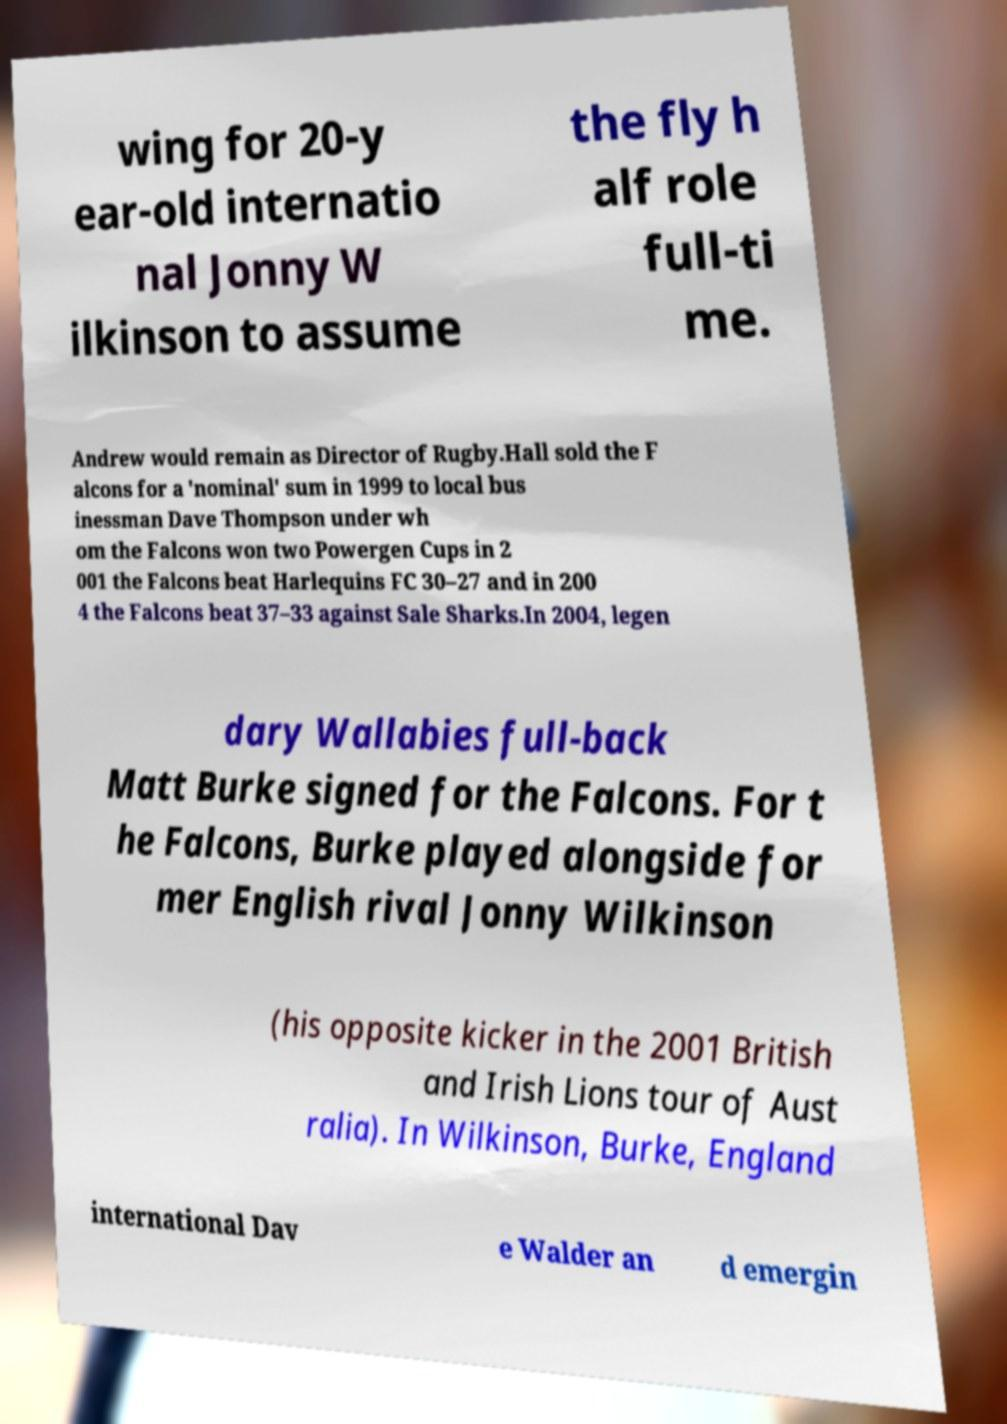I need the written content from this picture converted into text. Can you do that? wing for 20-y ear-old internatio nal Jonny W ilkinson to assume the fly h alf role full-ti me. Andrew would remain as Director of Rugby.Hall sold the F alcons for a 'nominal' sum in 1999 to local bus inessman Dave Thompson under wh om the Falcons won two Powergen Cups in 2 001 the Falcons beat Harlequins FC 30–27 and in 200 4 the Falcons beat 37–33 against Sale Sharks.In 2004, legen dary Wallabies full-back Matt Burke signed for the Falcons. For t he Falcons, Burke played alongside for mer English rival Jonny Wilkinson (his opposite kicker in the 2001 British and Irish Lions tour of Aust ralia). In Wilkinson, Burke, England international Dav e Walder an d emergin 